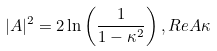<formula> <loc_0><loc_0><loc_500><loc_500>| A | ^ { 2 } = 2 \ln \left ( \frac { 1 } { 1 - \kappa ^ { 2 } } \right ) , R e A \kappa</formula> 